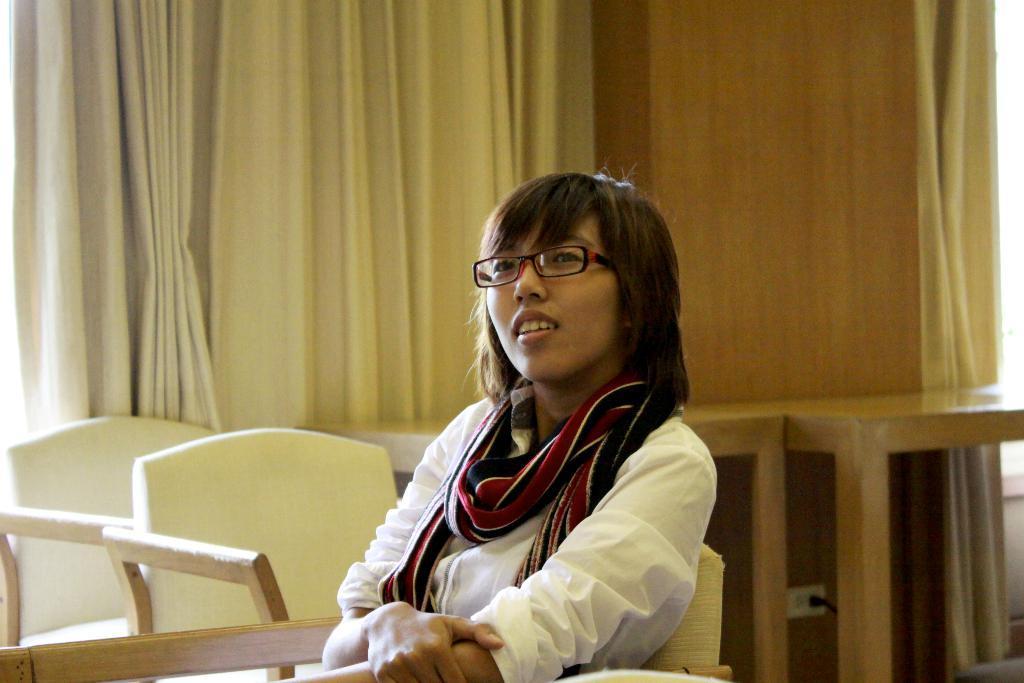Can you describe this image briefly? In this picture we can see a woman wore scarf, spectacle and sitting on chair and beside to her we have chairs, tables and in the background we can see wall, curtains. 